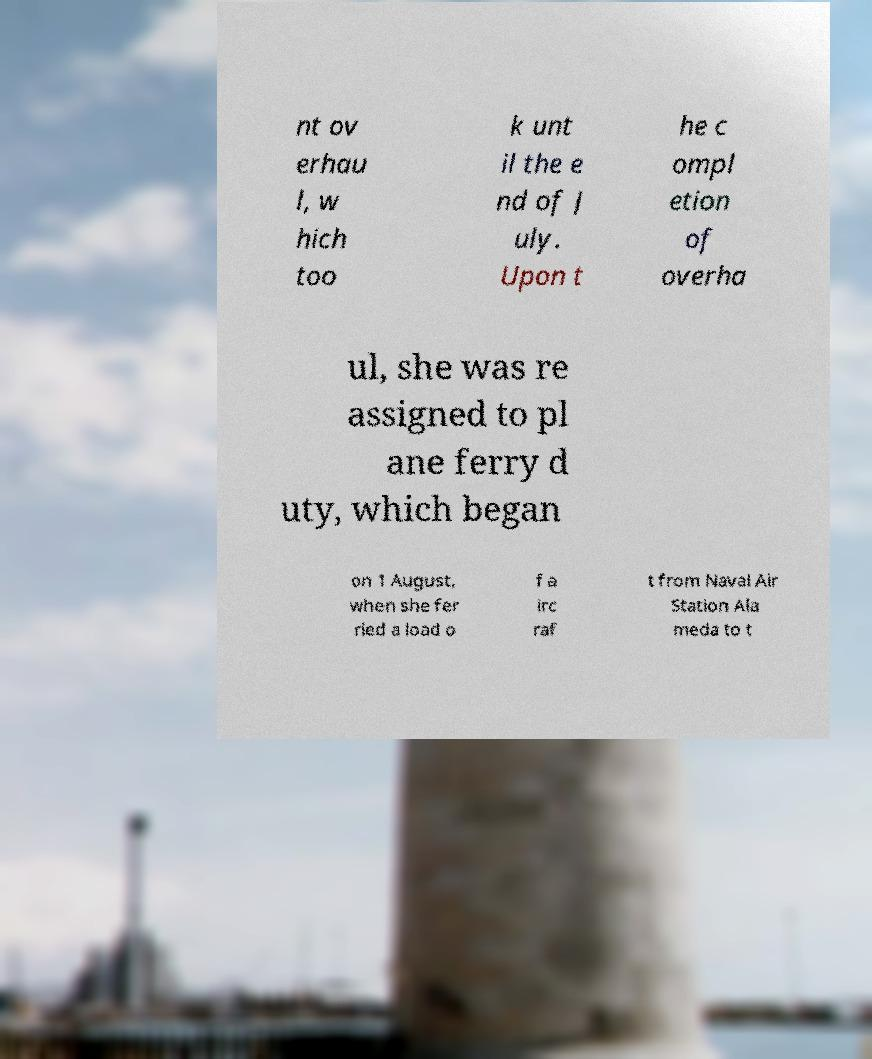There's text embedded in this image that I need extracted. Can you transcribe it verbatim? nt ov erhau l, w hich too k unt il the e nd of J uly. Upon t he c ompl etion of overha ul, she was re assigned to pl ane ferry d uty, which began on 1 August, when she fer ried a load o f a irc raf t from Naval Air Station Ala meda to t 